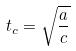<formula> <loc_0><loc_0><loc_500><loc_500>t _ { c } = \sqrt { \frac { a } { c } }</formula> 